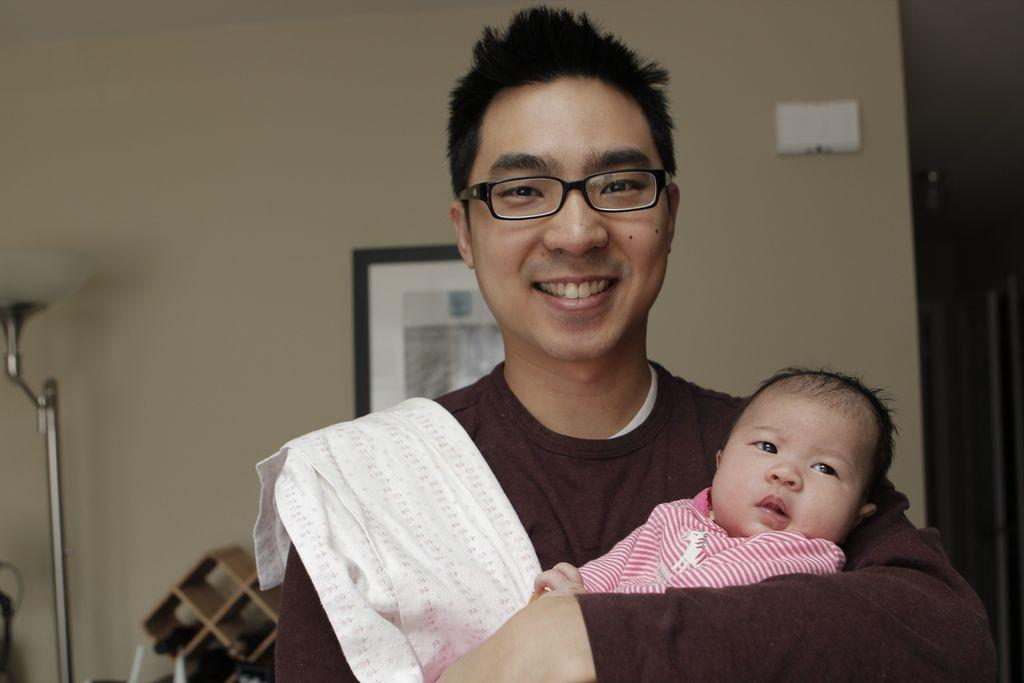What is the person in the image doing with the baby? The person is holding a baby in the image. Can you describe the person's appearance? The person is wearing spectacles and smiling. What can be seen in the background of the image? There is a lamp, an object, and a frame on the wall in the background of the image. How does the beetle roll across the floor in the image? There is no beetle present in the image, so it cannot roll across the floor. 